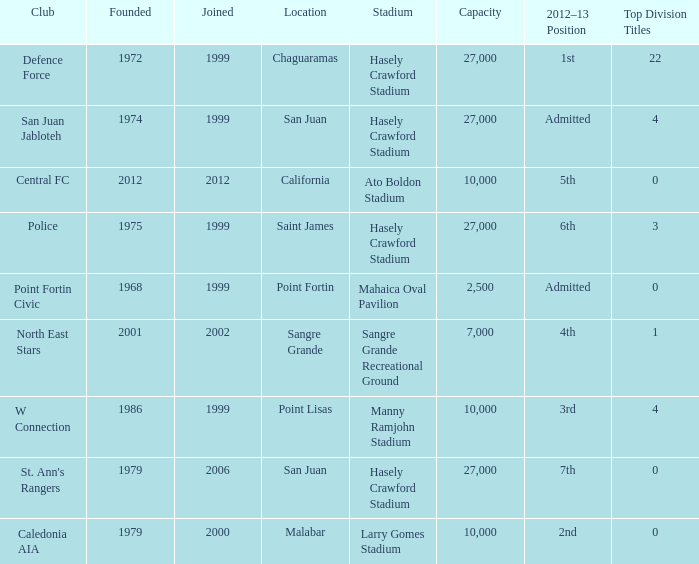What was the total number of Top Division Titles where the year founded was prior to 1975 and the location was in Chaguaramas? 22.0. 